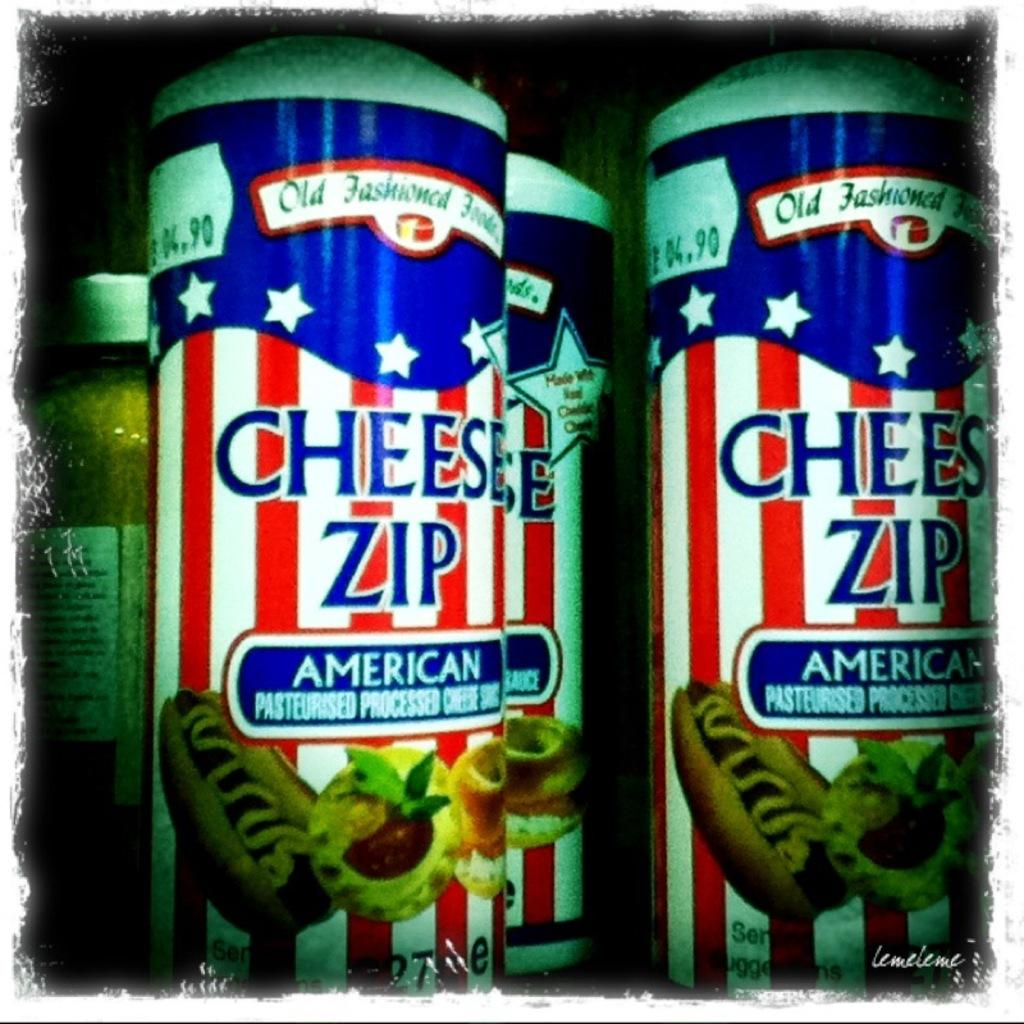<image>
Offer a succinct explanation of the picture presented. Several cans of old fashioned American Cheese Zip. 